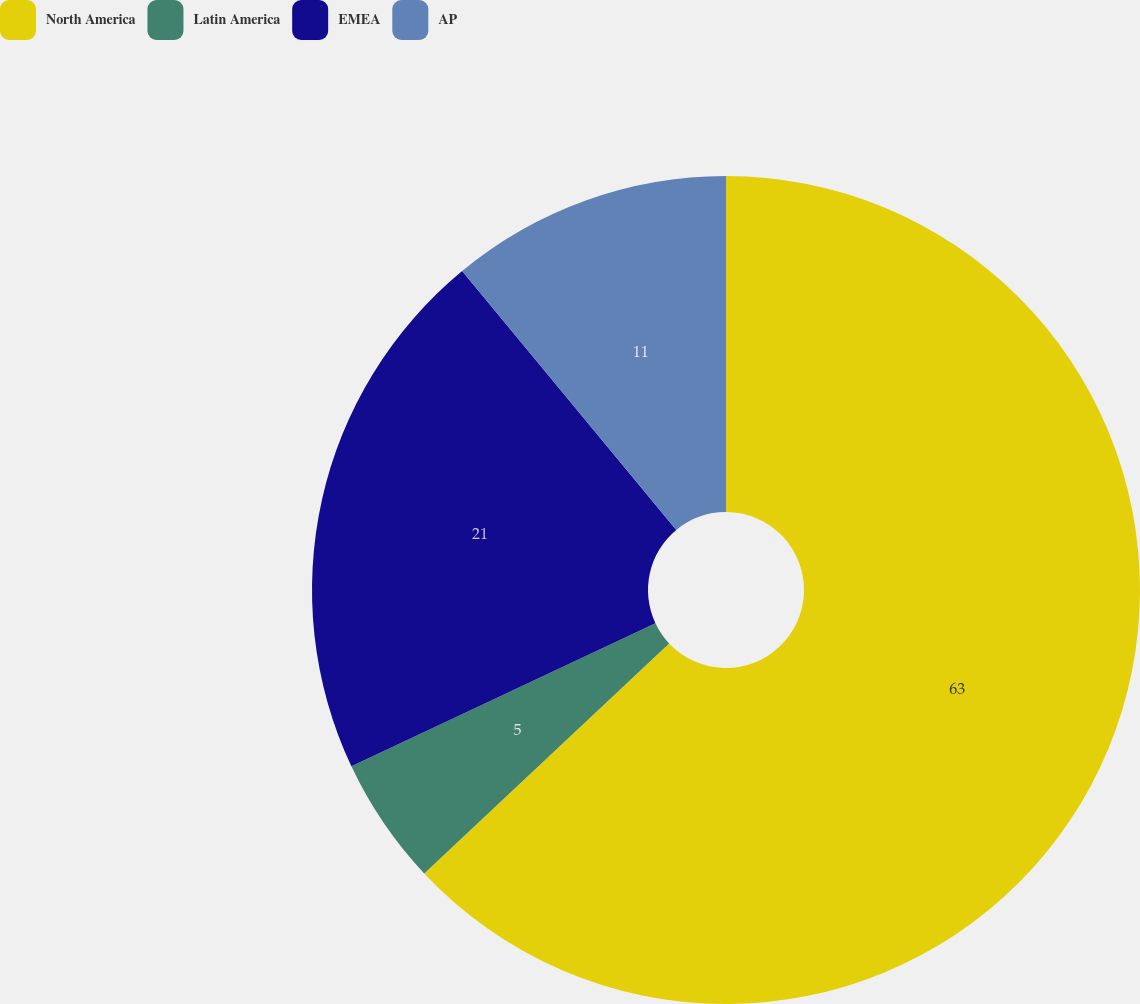Convert chart to OTSL. <chart><loc_0><loc_0><loc_500><loc_500><pie_chart><fcel>North America<fcel>Latin America<fcel>EMEA<fcel>AP<nl><fcel>63.0%<fcel>5.0%<fcel>21.0%<fcel>11.0%<nl></chart> 